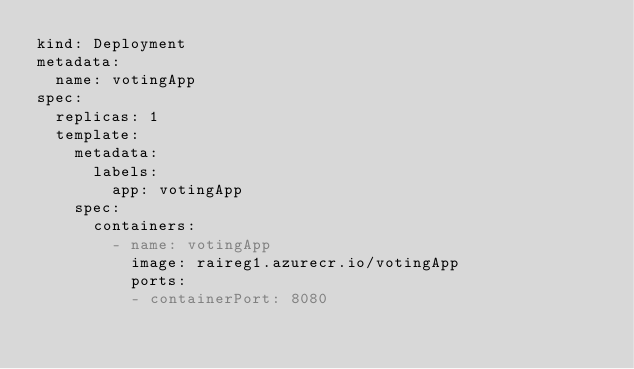Convert code to text. <code><loc_0><loc_0><loc_500><loc_500><_YAML_>kind: Deployment
metadata:
  name: votingApp 
spec:
  replicas: 1
  template:
    metadata:
      labels:
        app: votingApp 
    spec:
      containers:
        - name: votingApp 
          image: raireg1.azurecr.io/votingApp 
          ports:
          - containerPort: 8080</code> 